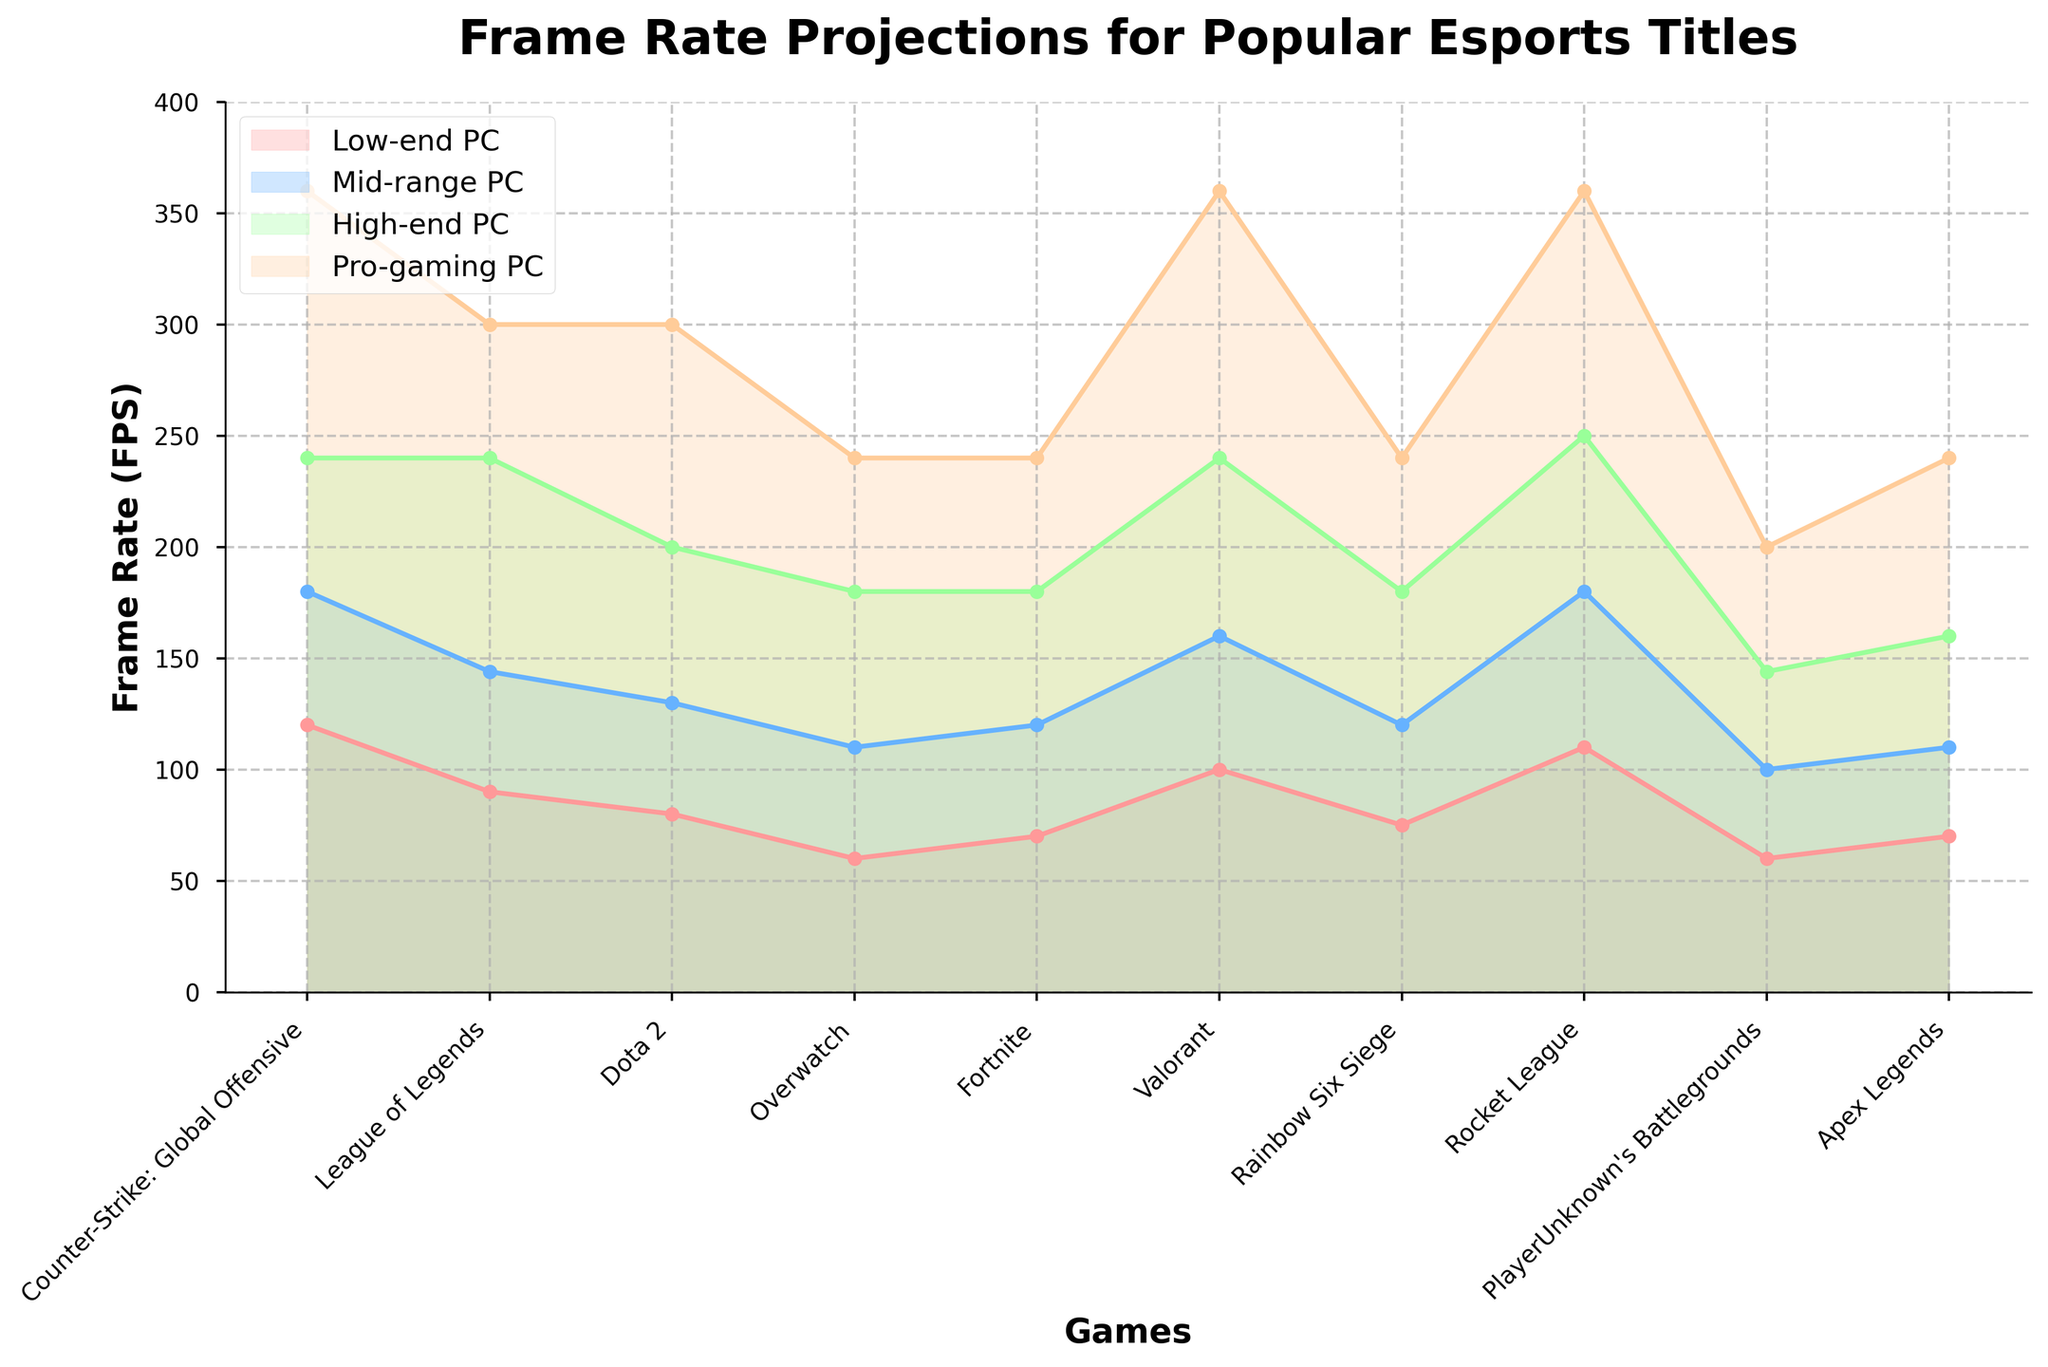What is the title of the figure? The title is typically at the top of the figure. Here, it reads "Frame Rate Projections for Popular Esports Titles".
Answer: Frame Rate Projections for Popular Esports Titles Which game shows the highest projected frame rate on a Pro-gaming PC? The highest frame rates in the Pro-gaming PC line are indicated by the uppermost angle in that line. Valorant and Counter-Strike: Global Offensive both show the highest frame rate with 360 FPS.
Answer: Valorant and Counter-Strike: Global Offensive How much higher is the frame rate for Dota 2 on a Pro-gaming PC compared to a Low-end PC? The frame rate for Dota 2 on a Pro-gaming PC is 300 FPS, while on a Low-end PC it is 80 FPS. Subtract 80 from 300 to find the difference: 300 - 80 = 220 FPS.
Answer: 220 FPS Which hardware configuration shows the most significant performance improvement for Overwatch? To determine this, check the differences in frame rates across configurations for Overwatch. Low-end to Mid-range (110 - 60 = 50), Mid-range to High-end (180 - 110 = 70), High-end to Pro-gaming (240 - 180 = 60). The largest increase is from Mid-range to High-end by 70 FPS.
Answer: Mid-range to High-end What is the range of frame rates for Rocket League across different PC configurations? The frame rates for Rocket League are listed as 110 for Low-end, 180 for Mid-range, 250 for High-end, and 360 for Pro-gaming PCs. The range is found by subtracting the lowest value from the highest value: 360 - 110 = 250 FPS.
Answer: 250 FPS Which games have the same frame rate on a Pro-gaming PC? Looking at the Pro-gaming PC values, Counter-Strike: Global Offensive, Valorant, and Rocket League all show the same frame rate of 360 FPS.
Answer: Counter-Strike: Global Offensive, Valorant, and Rocket League What is the average frame rate for Apex Legends across all hardware configurations? Sum the frame rates for Apex Legends: 70 (Low-end) + 110 (Mid-range) + 160 (High-end) + 240 (Pro-gaming) = 580 FPS. Then divide by the number of configurations (4): 580 / 4 = 145 FPS.
Answer: 145 FPS How does the frame rate of PlayerUnknown's Battlegrounds on a High-end PC compare to that on a Mid-range PC? The frame rate for PlayerUnknown's Battlegrounds is 144 FPS on a High-end PC and 100 FPS on a Mid-range PC. Subtract 100 from 144 to find the difference: 144 - 100 = 44 FPS.
Answer: 44 FPS higher Are there any games with identical frame rates on any two different hardware configurations? By comparing different lines, no two hardware configurations show identical frame rates for any of the games.
Answer: No 